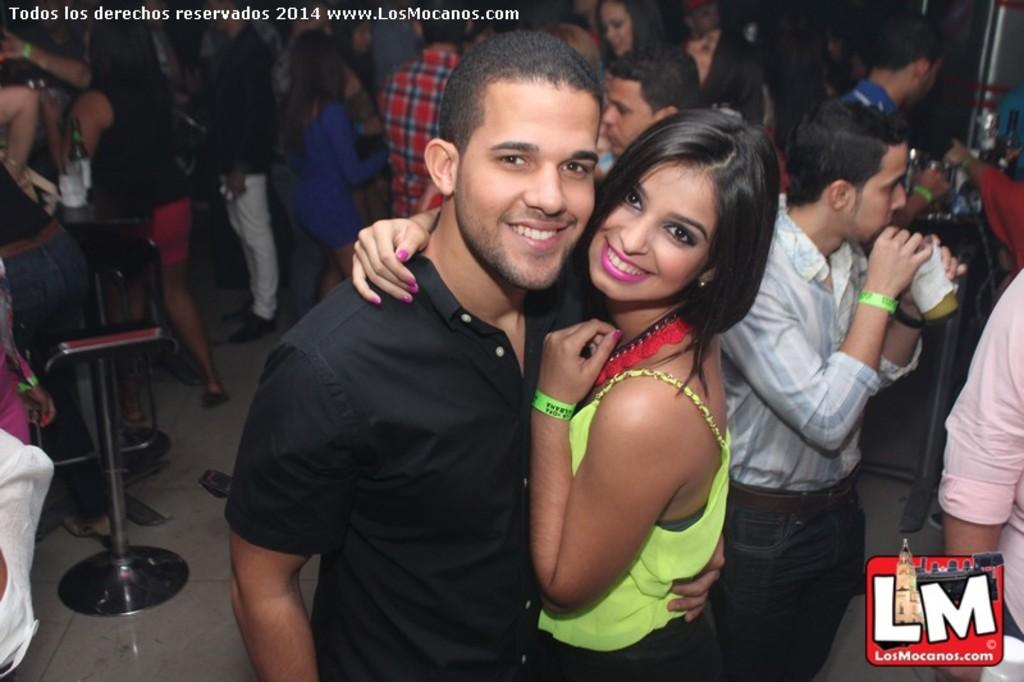How many people are visible in the image? There are two persons standing in the image. What is the facial expression of the two persons? The two persons are smiling. Are there any other people in the image besides the two persons? Yes, there is a group of people standing at the back. What can be seen on the table in the image? There are wine bottles on a table in the image. Can you see any planes flying over the ocean in the image? There is no plane or ocean present in the image; it features two persons standing and smiling, a group of people standing at the back, and wine bottles on a table. 